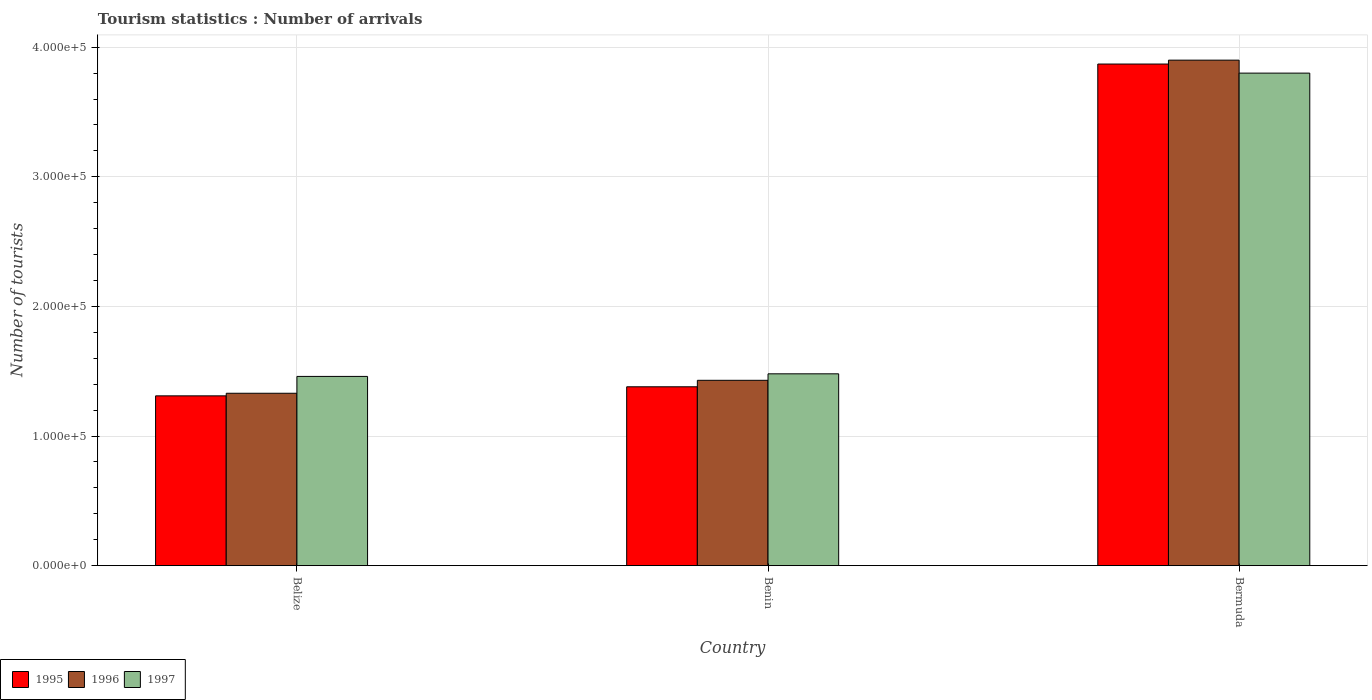How many groups of bars are there?
Ensure brevity in your answer.  3. Are the number of bars on each tick of the X-axis equal?
Provide a succinct answer. Yes. What is the label of the 3rd group of bars from the left?
Your response must be concise. Bermuda. In how many cases, is the number of bars for a given country not equal to the number of legend labels?
Keep it short and to the point. 0. What is the number of tourist arrivals in 1995 in Benin?
Provide a short and direct response. 1.38e+05. Across all countries, what is the maximum number of tourist arrivals in 1996?
Ensure brevity in your answer.  3.90e+05. Across all countries, what is the minimum number of tourist arrivals in 1997?
Give a very brief answer. 1.46e+05. In which country was the number of tourist arrivals in 1997 maximum?
Your answer should be compact. Bermuda. In which country was the number of tourist arrivals in 1996 minimum?
Offer a terse response. Belize. What is the total number of tourist arrivals in 1996 in the graph?
Give a very brief answer. 6.66e+05. What is the difference between the number of tourist arrivals in 1995 in Belize and that in Benin?
Give a very brief answer. -7000. What is the difference between the number of tourist arrivals in 1997 in Belize and the number of tourist arrivals in 1996 in Benin?
Your response must be concise. 3000. What is the average number of tourist arrivals in 1996 per country?
Your answer should be very brief. 2.22e+05. In how many countries, is the number of tourist arrivals in 1995 greater than 180000?
Offer a very short reply. 1. What is the ratio of the number of tourist arrivals in 1995 in Belize to that in Benin?
Your answer should be compact. 0.95. What is the difference between the highest and the second highest number of tourist arrivals in 1996?
Give a very brief answer. 2.57e+05. What is the difference between the highest and the lowest number of tourist arrivals in 1995?
Your answer should be very brief. 2.56e+05. What does the 3rd bar from the left in Benin represents?
Your answer should be compact. 1997. What does the 2nd bar from the right in Belize represents?
Give a very brief answer. 1996. How many countries are there in the graph?
Ensure brevity in your answer.  3. What is the difference between two consecutive major ticks on the Y-axis?
Give a very brief answer. 1.00e+05. Are the values on the major ticks of Y-axis written in scientific E-notation?
Your answer should be compact. Yes. Does the graph contain grids?
Provide a short and direct response. Yes. How are the legend labels stacked?
Your response must be concise. Horizontal. What is the title of the graph?
Offer a very short reply. Tourism statistics : Number of arrivals. What is the label or title of the Y-axis?
Provide a short and direct response. Number of tourists. What is the Number of tourists in 1995 in Belize?
Keep it short and to the point. 1.31e+05. What is the Number of tourists of 1996 in Belize?
Your response must be concise. 1.33e+05. What is the Number of tourists of 1997 in Belize?
Give a very brief answer. 1.46e+05. What is the Number of tourists in 1995 in Benin?
Your answer should be compact. 1.38e+05. What is the Number of tourists in 1996 in Benin?
Offer a very short reply. 1.43e+05. What is the Number of tourists of 1997 in Benin?
Offer a terse response. 1.48e+05. What is the Number of tourists in 1995 in Bermuda?
Provide a short and direct response. 3.87e+05. Across all countries, what is the maximum Number of tourists in 1995?
Keep it short and to the point. 3.87e+05. Across all countries, what is the maximum Number of tourists of 1997?
Make the answer very short. 3.80e+05. Across all countries, what is the minimum Number of tourists of 1995?
Your answer should be very brief. 1.31e+05. Across all countries, what is the minimum Number of tourists in 1996?
Offer a terse response. 1.33e+05. Across all countries, what is the minimum Number of tourists in 1997?
Provide a short and direct response. 1.46e+05. What is the total Number of tourists in 1995 in the graph?
Provide a succinct answer. 6.56e+05. What is the total Number of tourists in 1996 in the graph?
Your answer should be very brief. 6.66e+05. What is the total Number of tourists in 1997 in the graph?
Your answer should be very brief. 6.74e+05. What is the difference between the Number of tourists of 1995 in Belize and that in Benin?
Your answer should be compact. -7000. What is the difference between the Number of tourists of 1997 in Belize and that in Benin?
Give a very brief answer. -2000. What is the difference between the Number of tourists of 1995 in Belize and that in Bermuda?
Keep it short and to the point. -2.56e+05. What is the difference between the Number of tourists in 1996 in Belize and that in Bermuda?
Provide a succinct answer. -2.57e+05. What is the difference between the Number of tourists in 1997 in Belize and that in Bermuda?
Offer a very short reply. -2.34e+05. What is the difference between the Number of tourists of 1995 in Benin and that in Bermuda?
Keep it short and to the point. -2.49e+05. What is the difference between the Number of tourists of 1996 in Benin and that in Bermuda?
Give a very brief answer. -2.47e+05. What is the difference between the Number of tourists in 1997 in Benin and that in Bermuda?
Offer a terse response. -2.32e+05. What is the difference between the Number of tourists of 1995 in Belize and the Number of tourists of 1996 in Benin?
Your answer should be very brief. -1.20e+04. What is the difference between the Number of tourists in 1995 in Belize and the Number of tourists in 1997 in Benin?
Your answer should be very brief. -1.70e+04. What is the difference between the Number of tourists in 1996 in Belize and the Number of tourists in 1997 in Benin?
Provide a short and direct response. -1.50e+04. What is the difference between the Number of tourists in 1995 in Belize and the Number of tourists in 1996 in Bermuda?
Provide a succinct answer. -2.59e+05. What is the difference between the Number of tourists in 1995 in Belize and the Number of tourists in 1997 in Bermuda?
Your answer should be compact. -2.49e+05. What is the difference between the Number of tourists of 1996 in Belize and the Number of tourists of 1997 in Bermuda?
Provide a short and direct response. -2.47e+05. What is the difference between the Number of tourists in 1995 in Benin and the Number of tourists in 1996 in Bermuda?
Your response must be concise. -2.52e+05. What is the difference between the Number of tourists of 1995 in Benin and the Number of tourists of 1997 in Bermuda?
Keep it short and to the point. -2.42e+05. What is the difference between the Number of tourists of 1996 in Benin and the Number of tourists of 1997 in Bermuda?
Offer a very short reply. -2.37e+05. What is the average Number of tourists of 1995 per country?
Make the answer very short. 2.19e+05. What is the average Number of tourists of 1996 per country?
Offer a very short reply. 2.22e+05. What is the average Number of tourists of 1997 per country?
Keep it short and to the point. 2.25e+05. What is the difference between the Number of tourists in 1995 and Number of tourists in 1996 in Belize?
Offer a terse response. -2000. What is the difference between the Number of tourists in 1995 and Number of tourists in 1997 in Belize?
Your answer should be compact. -1.50e+04. What is the difference between the Number of tourists of 1996 and Number of tourists of 1997 in Belize?
Ensure brevity in your answer.  -1.30e+04. What is the difference between the Number of tourists in 1995 and Number of tourists in 1996 in Benin?
Your answer should be compact. -5000. What is the difference between the Number of tourists of 1995 and Number of tourists of 1997 in Benin?
Your answer should be compact. -10000. What is the difference between the Number of tourists in 1996 and Number of tourists in 1997 in Benin?
Make the answer very short. -5000. What is the difference between the Number of tourists in 1995 and Number of tourists in 1996 in Bermuda?
Ensure brevity in your answer.  -3000. What is the difference between the Number of tourists in 1995 and Number of tourists in 1997 in Bermuda?
Your response must be concise. 7000. What is the ratio of the Number of tourists in 1995 in Belize to that in Benin?
Ensure brevity in your answer.  0.95. What is the ratio of the Number of tourists of 1996 in Belize to that in Benin?
Keep it short and to the point. 0.93. What is the ratio of the Number of tourists of 1997 in Belize to that in Benin?
Your answer should be compact. 0.99. What is the ratio of the Number of tourists of 1995 in Belize to that in Bermuda?
Ensure brevity in your answer.  0.34. What is the ratio of the Number of tourists of 1996 in Belize to that in Bermuda?
Your answer should be compact. 0.34. What is the ratio of the Number of tourists in 1997 in Belize to that in Bermuda?
Keep it short and to the point. 0.38. What is the ratio of the Number of tourists of 1995 in Benin to that in Bermuda?
Your answer should be compact. 0.36. What is the ratio of the Number of tourists of 1996 in Benin to that in Bermuda?
Give a very brief answer. 0.37. What is the ratio of the Number of tourists of 1997 in Benin to that in Bermuda?
Your answer should be very brief. 0.39. What is the difference between the highest and the second highest Number of tourists of 1995?
Give a very brief answer. 2.49e+05. What is the difference between the highest and the second highest Number of tourists of 1996?
Your response must be concise. 2.47e+05. What is the difference between the highest and the second highest Number of tourists in 1997?
Provide a short and direct response. 2.32e+05. What is the difference between the highest and the lowest Number of tourists in 1995?
Make the answer very short. 2.56e+05. What is the difference between the highest and the lowest Number of tourists in 1996?
Keep it short and to the point. 2.57e+05. What is the difference between the highest and the lowest Number of tourists in 1997?
Your response must be concise. 2.34e+05. 